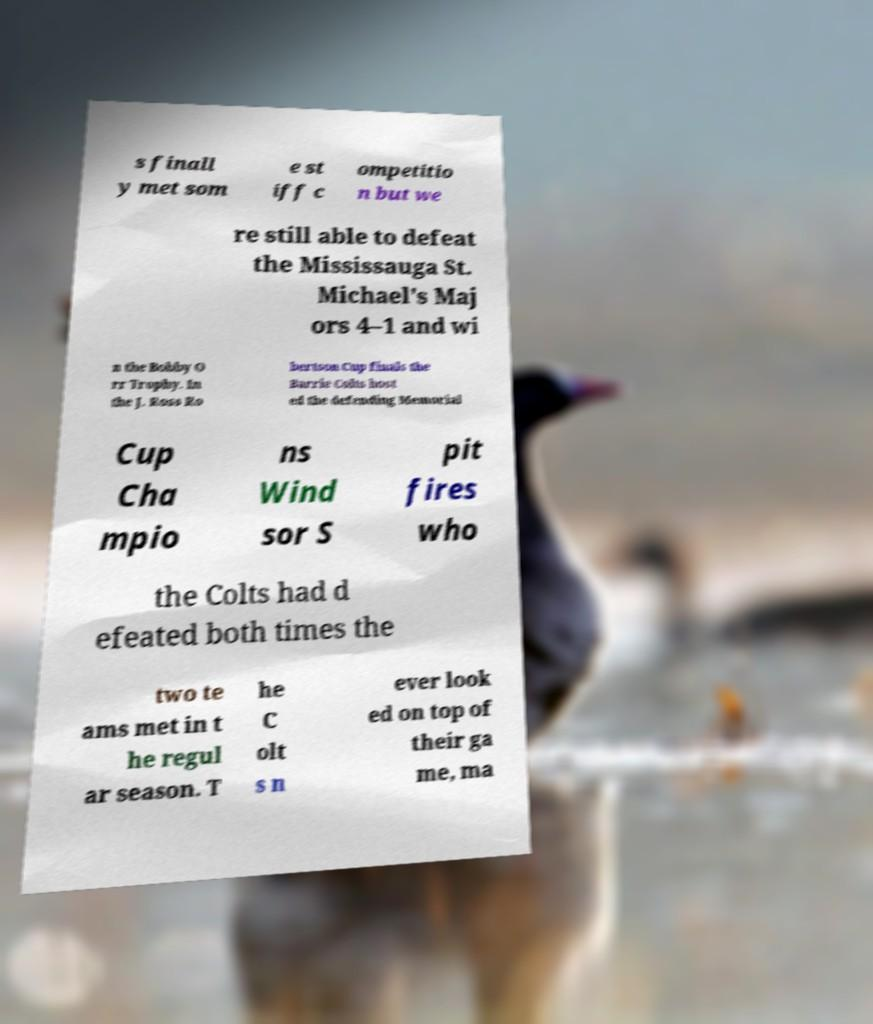Can you accurately transcribe the text from the provided image for me? s finall y met som e st iff c ompetitio n but we re still able to defeat the Mississauga St. Michael's Maj ors 4–1 and wi n the Bobby O rr Trophy. In the J. Ross Ro bertson Cup finals the Barrie Colts host ed the defending Memorial Cup Cha mpio ns Wind sor S pit fires who the Colts had d efeated both times the two te ams met in t he regul ar season. T he C olt s n ever look ed on top of their ga me, ma 